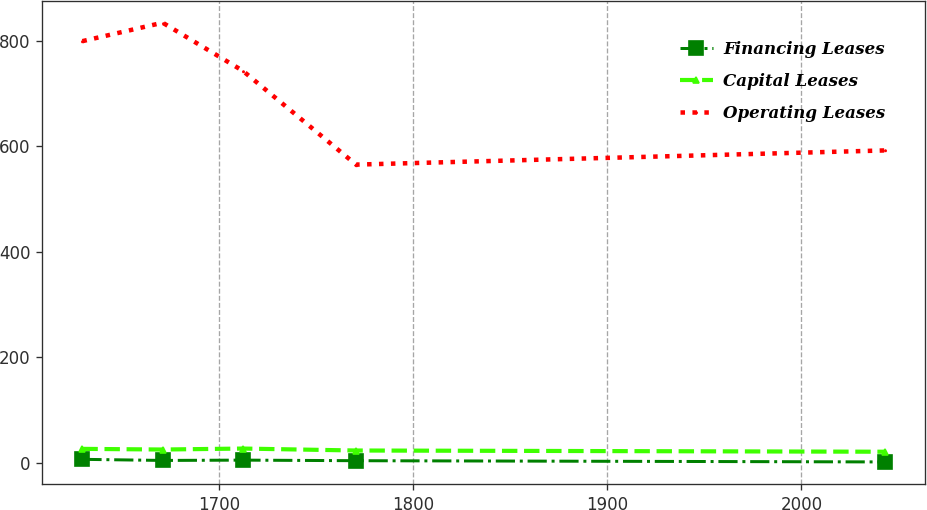Convert chart to OTSL. <chart><loc_0><loc_0><loc_500><loc_500><line_chart><ecel><fcel>Financing Leases<fcel>Capital Leases<fcel>Operating Leases<nl><fcel>1629.5<fcel>6.08<fcel>25.95<fcel>799.45<nl><fcel>1670.86<fcel>3.98<fcel>24.68<fcel>834.45<nl><fcel>1712.22<fcel>4.58<fcel>26.53<fcel>743.04<nl><fcel>1770.51<fcel>3.49<fcel>22.82<fcel>565.22<nl><fcel>2043.1<fcel>1.14<fcel>20.5<fcel>592.14<nl></chart> 